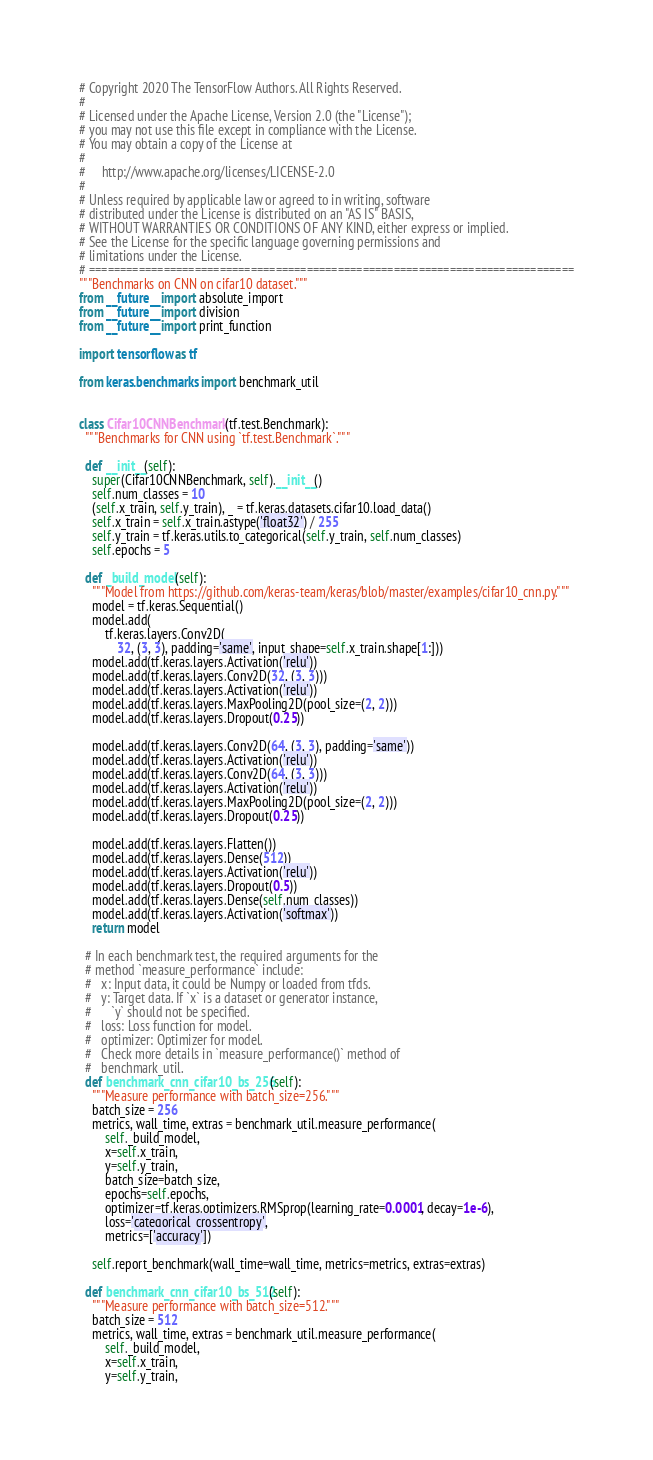Convert code to text. <code><loc_0><loc_0><loc_500><loc_500><_Python_># Copyright 2020 The TensorFlow Authors. All Rights Reserved.
#
# Licensed under the Apache License, Version 2.0 (the "License");
# you may not use this file except in compliance with the License.
# You may obtain a copy of the License at
#
#     http://www.apache.org/licenses/LICENSE-2.0
#
# Unless required by applicable law or agreed to in writing, software
# distributed under the License is distributed on an "AS IS" BASIS,
# WITHOUT WARRANTIES OR CONDITIONS OF ANY KIND, either express or implied.
# See the License for the specific language governing permissions and
# limitations under the License.
# ==============================================================================
"""Benchmarks on CNN on cifar10 dataset."""
from __future__ import absolute_import
from __future__ import division
from __future__ import print_function

import tensorflow as tf

from keras.benchmarks import benchmark_util


class Cifar10CNNBenchmark(tf.test.Benchmark):
  """Benchmarks for CNN using `tf.test.Benchmark`."""

  def __init__(self):
    super(Cifar10CNNBenchmark, self).__init__()
    self.num_classes = 10
    (self.x_train, self.y_train), _ = tf.keras.datasets.cifar10.load_data()
    self.x_train = self.x_train.astype('float32') / 255
    self.y_train = tf.keras.utils.to_categorical(self.y_train, self.num_classes)
    self.epochs = 5

  def _build_model(self):
    """Model from https://github.com/keras-team/keras/blob/master/examples/cifar10_cnn.py."""
    model = tf.keras.Sequential()
    model.add(
        tf.keras.layers.Conv2D(
            32, (3, 3), padding='same', input_shape=self.x_train.shape[1:]))
    model.add(tf.keras.layers.Activation('relu'))
    model.add(tf.keras.layers.Conv2D(32, (3, 3)))
    model.add(tf.keras.layers.Activation('relu'))
    model.add(tf.keras.layers.MaxPooling2D(pool_size=(2, 2)))
    model.add(tf.keras.layers.Dropout(0.25))

    model.add(tf.keras.layers.Conv2D(64, (3, 3), padding='same'))
    model.add(tf.keras.layers.Activation('relu'))
    model.add(tf.keras.layers.Conv2D(64, (3, 3)))
    model.add(tf.keras.layers.Activation('relu'))
    model.add(tf.keras.layers.MaxPooling2D(pool_size=(2, 2)))
    model.add(tf.keras.layers.Dropout(0.25))

    model.add(tf.keras.layers.Flatten())
    model.add(tf.keras.layers.Dense(512))
    model.add(tf.keras.layers.Activation('relu'))
    model.add(tf.keras.layers.Dropout(0.5))
    model.add(tf.keras.layers.Dense(self.num_classes))
    model.add(tf.keras.layers.Activation('softmax'))
    return model

  # In each benchmark test, the required arguments for the
  # method `measure_performance` include:
  #   x: Input data, it could be Numpy or loaded from tfds.
  #   y: Target data. If `x` is a dataset or generator instance,
  #      `y` should not be specified.
  #   loss: Loss function for model.
  #   optimizer: Optimizer for model.
  #   Check more details in `measure_performance()` method of
  #   benchmark_util.
  def benchmark_cnn_cifar10_bs_256(self):
    """Measure performance with batch_size=256."""
    batch_size = 256
    metrics, wall_time, extras = benchmark_util.measure_performance(
        self._build_model,
        x=self.x_train,
        y=self.y_train,
        batch_size=batch_size,
        epochs=self.epochs,
        optimizer=tf.keras.optimizers.RMSprop(learning_rate=0.0001, decay=1e-6),
        loss='categorical_crossentropy',
        metrics=['accuracy'])

    self.report_benchmark(wall_time=wall_time, metrics=metrics, extras=extras)

  def benchmark_cnn_cifar10_bs_512(self):
    """Measure performance with batch_size=512."""
    batch_size = 512
    metrics, wall_time, extras = benchmark_util.measure_performance(
        self._build_model,
        x=self.x_train,
        y=self.y_train,</code> 